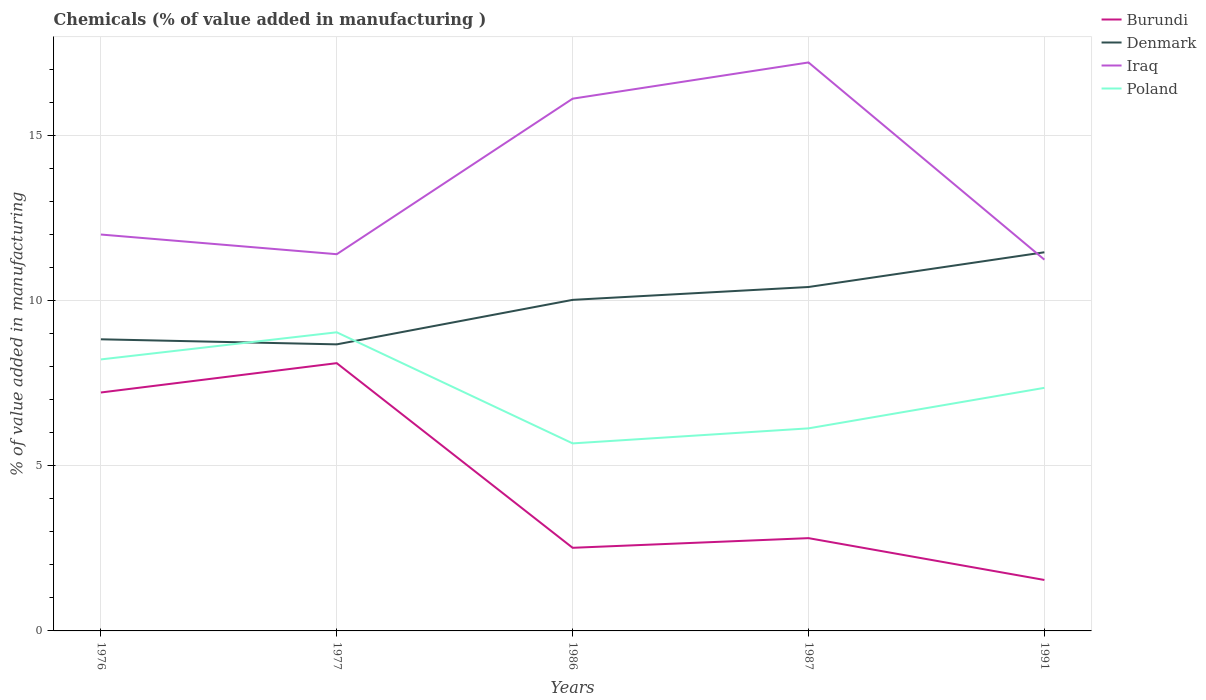Is the number of lines equal to the number of legend labels?
Provide a short and direct response. Yes. Across all years, what is the maximum value added in manufacturing chemicals in Denmark?
Offer a terse response. 8.68. In which year was the value added in manufacturing chemicals in Denmark maximum?
Keep it short and to the point. 1977. What is the total value added in manufacturing chemicals in Burundi in the graph?
Give a very brief answer. 5.68. What is the difference between the highest and the second highest value added in manufacturing chemicals in Burundi?
Give a very brief answer. 6.57. What is the difference between the highest and the lowest value added in manufacturing chemicals in Burundi?
Your answer should be compact. 2. Is the value added in manufacturing chemicals in Denmark strictly greater than the value added in manufacturing chemicals in Burundi over the years?
Provide a succinct answer. No. How many years are there in the graph?
Keep it short and to the point. 5. What is the difference between two consecutive major ticks on the Y-axis?
Your answer should be compact. 5. Does the graph contain grids?
Ensure brevity in your answer.  Yes. What is the title of the graph?
Offer a terse response. Chemicals (% of value added in manufacturing ). What is the label or title of the X-axis?
Provide a succinct answer. Years. What is the label or title of the Y-axis?
Provide a succinct answer. % of value added in manufacturing. What is the % of value added in manufacturing in Burundi in 1976?
Your answer should be compact. 7.22. What is the % of value added in manufacturing in Denmark in 1976?
Keep it short and to the point. 8.83. What is the % of value added in manufacturing in Iraq in 1976?
Your answer should be very brief. 12. What is the % of value added in manufacturing in Poland in 1976?
Offer a very short reply. 8.22. What is the % of value added in manufacturing of Burundi in 1977?
Give a very brief answer. 8.11. What is the % of value added in manufacturing in Denmark in 1977?
Provide a short and direct response. 8.68. What is the % of value added in manufacturing of Iraq in 1977?
Offer a very short reply. 11.41. What is the % of value added in manufacturing of Poland in 1977?
Your response must be concise. 9.04. What is the % of value added in manufacturing in Burundi in 1986?
Make the answer very short. 2.52. What is the % of value added in manufacturing in Denmark in 1986?
Offer a terse response. 10.02. What is the % of value added in manufacturing of Iraq in 1986?
Your response must be concise. 16.12. What is the % of value added in manufacturing in Poland in 1986?
Provide a succinct answer. 5.68. What is the % of value added in manufacturing of Burundi in 1987?
Make the answer very short. 2.81. What is the % of value added in manufacturing of Denmark in 1987?
Offer a very short reply. 10.41. What is the % of value added in manufacturing of Iraq in 1987?
Ensure brevity in your answer.  17.21. What is the % of value added in manufacturing in Poland in 1987?
Ensure brevity in your answer.  6.13. What is the % of value added in manufacturing of Burundi in 1991?
Provide a succinct answer. 1.54. What is the % of value added in manufacturing in Denmark in 1991?
Your response must be concise. 11.47. What is the % of value added in manufacturing in Iraq in 1991?
Make the answer very short. 11.24. What is the % of value added in manufacturing of Poland in 1991?
Keep it short and to the point. 7.36. Across all years, what is the maximum % of value added in manufacturing in Burundi?
Your answer should be very brief. 8.11. Across all years, what is the maximum % of value added in manufacturing in Denmark?
Offer a very short reply. 11.47. Across all years, what is the maximum % of value added in manufacturing of Iraq?
Make the answer very short. 17.21. Across all years, what is the maximum % of value added in manufacturing in Poland?
Your response must be concise. 9.04. Across all years, what is the minimum % of value added in manufacturing of Burundi?
Make the answer very short. 1.54. Across all years, what is the minimum % of value added in manufacturing in Denmark?
Ensure brevity in your answer.  8.68. Across all years, what is the minimum % of value added in manufacturing in Iraq?
Your answer should be very brief. 11.24. Across all years, what is the minimum % of value added in manufacturing of Poland?
Ensure brevity in your answer.  5.68. What is the total % of value added in manufacturing in Burundi in the graph?
Your response must be concise. 22.2. What is the total % of value added in manufacturing in Denmark in the graph?
Ensure brevity in your answer.  49.41. What is the total % of value added in manufacturing of Iraq in the graph?
Provide a succinct answer. 67.98. What is the total % of value added in manufacturing of Poland in the graph?
Your answer should be very brief. 36.44. What is the difference between the % of value added in manufacturing of Burundi in 1976 and that in 1977?
Offer a terse response. -0.89. What is the difference between the % of value added in manufacturing of Denmark in 1976 and that in 1977?
Offer a terse response. 0.15. What is the difference between the % of value added in manufacturing of Iraq in 1976 and that in 1977?
Make the answer very short. 0.6. What is the difference between the % of value added in manufacturing of Poland in 1976 and that in 1977?
Your response must be concise. -0.82. What is the difference between the % of value added in manufacturing of Burundi in 1976 and that in 1986?
Offer a terse response. 4.7. What is the difference between the % of value added in manufacturing of Denmark in 1976 and that in 1986?
Offer a very short reply. -1.19. What is the difference between the % of value added in manufacturing of Iraq in 1976 and that in 1986?
Ensure brevity in your answer.  -4.11. What is the difference between the % of value added in manufacturing of Poland in 1976 and that in 1986?
Offer a very short reply. 2.54. What is the difference between the % of value added in manufacturing in Burundi in 1976 and that in 1987?
Provide a short and direct response. 4.41. What is the difference between the % of value added in manufacturing in Denmark in 1976 and that in 1987?
Provide a succinct answer. -1.58. What is the difference between the % of value added in manufacturing of Iraq in 1976 and that in 1987?
Provide a succinct answer. -5.21. What is the difference between the % of value added in manufacturing of Poland in 1976 and that in 1987?
Ensure brevity in your answer.  2.09. What is the difference between the % of value added in manufacturing of Burundi in 1976 and that in 1991?
Provide a short and direct response. 5.68. What is the difference between the % of value added in manufacturing in Denmark in 1976 and that in 1991?
Offer a terse response. -2.63. What is the difference between the % of value added in manufacturing in Iraq in 1976 and that in 1991?
Offer a terse response. 0.76. What is the difference between the % of value added in manufacturing in Poland in 1976 and that in 1991?
Keep it short and to the point. 0.86. What is the difference between the % of value added in manufacturing in Burundi in 1977 and that in 1986?
Your response must be concise. 5.59. What is the difference between the % of value added in manufacturing of Denmark in 1977 and that in 1986?
Offer a very short reply. -1.35. What is the difference between the % of value added in manufacturing of Iraq in 1977 and that in 1986?
Make the answer very short. -4.71. What is the difference between the % of value added in manufacturing in Poland in 1977 and that in 1986?
Your answer should be very brief. 3.36. What is the difference between the % of value added in manufacturing of Burundi in 1977 and that in 1987?
Make the answer very short. 5.3. What is the difference between the % of value added in manufacturing of Denmark in 1977 and that in 1987?
Provide a short and direct response. -1.74. What is the difference between the % of value added in manufacturing in Iraq in 1977 and that in 1987?
Provide a succinct answer. -5.81. What is the difference between the % of value added in manufacturing in Poland in 1977 and that in 1987?
Provide a succinct answer. 2.91. What is the difference between the % of value added in manufacturing of Burundi in 1977 and that in 1991?
Offer a terse response. 6.57. What is the difference between the % of value added in manufacturing in Denmark in 1977 and that in 1991?
Offer a terse response. -2.79. What is the difference between the % of value added in manufacturing of Iraq in 1977 and that in 1991?
Offer a very short reply. 0.17. What is the difference between the % of value added in manufacturing of Poland in 1977 and that in 1991?
Keep it short and to the point. 1.68. What is the difference between the % of value added in manufacturing of Burundi in 1986 and that in 1987?
Your response must be concise. -0.29. What is the difference between the % of value added in manufacturing of Denmark in 1986 and that in 1987?
Provide a short and direct response. -0.39. What is the difference between the % of value added in manufacturing in Iraq in 1986 and that in 1987?
Your answer should be compact. -1.1. What is the difference between the % of value added in manufacturing in Poland in 1986 and that in 1987?
Provide a succinct answer. -0.46. What is the difference between the % of value added in manufacturing in Burundi in 1986 and that in 1991?
Make the answer very short. 0.97. What is the difference between the % of value added in manufacturing in Denmark in 1986 and that in 1991?
Make the answer very short. -1.44. What is the difference between the % of value added in manufacturing of Iraq in 1986 and that in 1991?
Provide a succinct answer. 4.87. What is the difference between the % of value added in manufacturing of Poland in 1986 and that in 1991?
Provide a short and direct response. -1.68. What is the difference between the % of value added in manufacturing in Burundi in 1987 and that in 1991?
Ensure brevity in your answer.  1.27. What is the difference between the % of value added in manufacturing of Denmark in 1987 and that in 1991?
Keep it short and to the point. -1.05. What is the difference between the % of value added in manufacturing of Iraq in 1987 and that in 1991?
Provide a short and direct response. 5.97. What is the difference between the % of value added in manufacturing in Poland in 1987 and that in 1991?
Keep it short and to the point. -1.23. What is the difference between the % of value added in manufacturing of Burundi in 1976 and the % of value added in manufacturing of Denmark in 1977?
Your response must be concise. -1.46. What is the difference between the % of value added in manufacturing of Burundi in 1976 and the % of value added in manufacturing of Iraq in 1977?
Give a very brief answer. -4.19. What is the difference between the % of value added in manufacturing in Burundi in 1976 and the % of value added in manufacturing in Poland in 1977?
Provide a short and direct response. -1.82. What is the difference between the % of value added in manufacturing of Denmark in 1976 and the % of value added in manufacturing of Iraq in 1977?
Make the answer very short. -2.58. What is the difference between the % of value added in manufacturing of Denmark in 1976 and the % of value added in manufacturing of Poland in 1977?
Provide a short and direct response. -0.21. What is the difference between the % of value added in manufacturing of Iraq in 1976 and the % of value added in manufacturing of Poland in 1977?
Make the answer very short. 2.96. What is the difference between the % of value added in manufacturing of Burundi in 1976 and the % of value added in manufacturing of Denmark in 1986?
Ensure brevity in your answer.  -2.8. What is the difference between the % of value added in manufacturing of Burundi in 1976 and the % of value added in manufacturing of Iraq in 1986?
Your answer should be very brief. -8.9. What is the difference between the % of value added in manufacturing in Burundi in 1976 and the % of value added in manufacturing in Poland in 1986?
Ensure brevity in your answer.  1.54. What is the difference between the % of value added in manufacturing in Denmark in 1976 and the % of value added in manufacturing in Iraq in 1986?
Make the answer very short. -7.29. What is the difference between the % of value added in manufacturing of Denmark in 1976 and the % of value added in manufacturing of Poland in 1986?
Your answer should be very brief. 3.15. What is the difference between the % of value added in manufacturing of Iraq in 1976 and the % of value added in manufacturing of Poland in 1986?
Give a very brief answer. 6.32. What is the difference between the % of value added in manufacturing of Burundi in 1976 and the % of value added in manufacturing of Denmark in 1987?
Offer a terse response. -3.19. What is the difference between the % of value added in manufacturing in Burundi in 1976 and the % of value added in manufacturing in Iraq in 1987?
Give a very brief answer. -9.99. What is the difference between the % of value added in manufacturing in Burundi in 1976 and the % of value added in manufacturing in Poland in 1987?
Your response must be concise. 1.09. What is the difference between the % of value added in manufacturing of Denmark in 1976 and the % of value added in manufacturing of Iraq in 1987?
Make the answer very short. -8.38. What is the difference between the % of value added in manufacturing of Denmark in 1976 and the % of value added in manufacturing of Poland in 1987?
Provide a succinct answer. 2.7. What is the difference between the % of value added in manufacturing of Iraq in 1976 and the % of value added in manufacturing of Poland in 1987?
Provide a short and direct response. 5.87. What is the difference between the % of value added in manufacturing of Burundi in 1976 and the % of value added in manufacturing of Denmark in 1991?
Your answer should be very brief. -4.25. What is the difference between the % of value added in manufacturing of Burundi in 1976 and the % of value added in manufacturing of Iraq in 1991?
Make the answer very short. -4.02. What is the difference between the % of value added in manufacturing in Burundi in 1976 and the % of value added in manufacturing in Poland in 1991?
Make the answer very short. -0.14. What is the difference between the % of value added in manufacturing in Denmark in 1976 and the % of value added in manufacturing in Iraq in 1991?
Offer a very short reply. -2.41. What is the difference between the % of value added in manufacturing of Denmark in 1976 and the % of value added in manufacturing of Poland in 1991?
Give a very brief answer. 1.47. What is the difference between the % of value added in manufacturing in Iraq in 1976 and the % of value added in manufacturing in Poland in 1991?
Your answer should be very brief. 4.64. What is the difference between the % of value added in manufacturing of Burundi in 1977 and the % of value added in manufacturing of Denmark in 1986?
Provide a succinct answer. -1.92. What is the difference between the % of value added in manufacturing in Burundi in 1977 and the % of value added in manufacturing in Iraq in 1986?
Your answer should be compact. -8.01. What is the difference between the % of value added in manufacturing in Burundi in 1977 and the % of value added in manufacturing in Poland in 1986?
Your answer should be compact. 2.43. What is the difference between the % of value added in manufacturing in Denmark in 1977 and the % of value added in manufacturing in Iraq in 1986?
Provide a succinct answer. -7.44. What is the difference between the % of value added in manufacturing in Denmark in 1977 and the % of value added in manufacturing in Poland in 1986?
Offer a very short reply. 3. What is the difference between the % of value added in manufacturing of Iraq in 1977 and the % of value added in manufacturing of Poland in 1986?
Your answer should be compact. 5.73. What is the difference between the % of value added in manufacturing of Burundi in 1977 and the % of value added in manufacturing of Denmark in 1987?
Your answer should be very brief. -2.31. What is the difference between the % of value added in manufacturing of Burundi in 1977 and the % of value added in manufacturing of Iraq in 1987?
Offer a very short reply. -9.11. What is the difference between the % of value added in manufacturing of Burundi in 1977 and the % of value added in manufacturing of Poland in 1987?
Your answer should be very brief. 1.97. What is the difference between the % of value added in manufacturing of Denmark in 1977 and the % of value added in manufacturing of Iraq in 1987?
Provide a short and direct response. -8.54. What is the difference between the % of value added in manufacturing of Denmark in 1977 and the % of value added in manufacturing of Poland in 1987?
Make the answer very short. 2.54. What is the difference between the % of value added in manufacturing of Iraq in 1977 and the % of value added in manufacturing of Poland in 1987?
Your answer should be very brief. 5.27. What is the difference between the % of value added in manufacturing in Burundi in 1977 and the % of value added in manufacturing in Denmark in 1991?
Offer a terse response. -3.36. What is the difference between the % of value added in manufacturing in Burundi in 1977 and the % of value added in manufacturing in Iraq in 1991?
Offer a very short reply. -3.13. What is the difference between the % of value added in manufacturing in Burundi in 1977 and the % of value added in manufacturing in Poland in 1991?
Keep it short and to the point. 0.75. What is the difference between the % of value added in manufacturing in Denmark in 1977 and the % of value added in manufacturing in Iraq in 1991?
Your response must be concise. -2.57. What is the difference between the % of value added in manufacturing of Denmark in 1977 and the % of value added in manufacturing of Poland in 1991?
Provide a succinct answer. 1.32. What is the difference between the % of value added in manufacturing in Iraq in 1977 and the % of value added in manufacturing in Poland in 1991?
Offer a terse response. 4.05. What is the difference between the % of value added in manufacturing of Burundi in 1986 and the % of value added in manufacturing of Denmark in 1987?
Offer a very short reply. -7.9. What is the difference between the % of value added in manufacturing of Burundi in 1986 and the % of value added in manufacturing of Iraq in 1987?
Your response must be concise. -14.7. What is the difference between the % of value added in manufacturing of Burundi in 1986 and the % of value added in manufacturing of Poland in 1987?
Keep it short and to the point. -3.62. What is the difference between the % of value added in manufacturing of Denmark in 1986 and the % of value added in manufacturing of Iraq in 1987?
Keep it short and to the point. -7.19. What is the difference between the % of value added in manufacturing of Denmark in 1986 and the % of value added in manufacturing of Poland in 1987?
Your answer should be very brief. 3.89. What is the difference between the % of value added in manufacturing of Iraq in 1986 and the % of value added in manufacturing of Poland in 1987?
Make the answer very short. 9.98. What is the difference between the % of value added in manufacturing in Burundi in 1986 and the % of value added in manufacturing in Denmark in 1991?
Give a very brief answer. -8.95. What is the difference between the % of value added in manufacturing in Burundi in 1986 and the % of value added in manufacturing in Iraq in 1991?
Offer a terse response. -8.73. What is the difference between the % of value added in manufacturing of Burundi in 1986 and the % of value added in manufacturing of Poland in 1991?
Make the answer very short. -4.84. What is the difference between the % of value added in manufacturing of Denmark in 1986 and the % of value added in manufacturing of Iraq in 1991?
Make the answer very short. -1.22. What is the difference between the % of value added in manufacturing in Denmark in 1986 and the % of value added in manufacturing in Poland in 1991?
Your answer should be very brief. 2.66. What is the difference between the % of value added in manufacturing of Iraq in 1986 and the % of value added in manufacturing of Poland in 1991?
Offer a very short reply. 8.76. What is the difference between the % of value added in manufacturing in Burundi in 1987 and the % of value added in manufacturing in Denmark in 1991?
Ensure brevity in your answer.  -8.66. What is the difference between the % of value added in manufacturing of Burundi in 1987 and the % of value added in manufacturing of Iraq in 1991?
Provide a short and direct response. -8.43. What is the difference between the % of value added in manufacturing in Burundi in 1987 and the % of value added in manufacturing in Poland in 1991?
Keep it short and to the point. -4.55. What is the difference between the % of value added in manufacturing in Denmark in 1987 and the % of value added in manufacturing in Iraq in 1991?
Make the answer very short. -0.83. What is the difference between the % of value added in manufacturing of Denmark in 1987 and the % of value added in manufacturing of Poland in 1991?
Your answer should be compact. 3.05. What is the difference between the % of value added in manufacturing of Iraq in 1987 and the % of value added in manufacturing of Poland in 1991?
Give a very brief answer. 9.85. What is the average % of value added in manufacturing in Burundi per year?
Ensure brevity in your answer.  4.44. What is the average % of value added in manufacturing in Denmark per year?
Provide a succinct answer. 9.88. What is the average % of value added in manufacturing in Iraq per year?
Give a very brief answer. 13.6. What is the average % of value added in manufacturing in Poland per year?
Provide a succinct answer. 7.29. In the year 1976, what is the difference between the % of value added in manufacturing of Burundi and % of value added in manufacturing of Denmark?
Ensure brevity in your answer.  -1.61. In the year 1976, what is the difference between the % of value added in manufacturing in Burundi and % of value added in manufacturing in Iraq?
Your answer should be very brief. -4.78. In the year 1976, what is the difference between the % of value added in manufacturing of Burundi and % of value added in manufacturing of Poland?
Offer a very short reply. -1. In the year 1976, what is the difference between the % of value added in manufacturing of Denmark and % of value added in manufacturing of Iraq?
Offer a very short reply. -3.17. In the year 1976, what is the difference between the % of value added in manufacturing of Denmark and % of value added in manufacturing of Poland?
Your answer should be compact. 0.61. In the year 1976, what is the difference between the % of value added in manufacturing of Iraq and % of value added in manufacturing of Poland?
Ensure brevity in your answer.  3.78. In the year 1977, what is the difference between the % of value added in manufacturing of Burundi and % of value added in manufacturing of Denmark?
Provide a short and direct response. -0.57. In the year 1977, what is the difference between the % of value added in manufacturing of Burundi and % of value added in manufacturing of Iraq?
Your answer should be compact. -3.3. In the year 1977, what is the difference between the % of value added in manufacturing in Burundi and % of value added in manufacturing in Poland?
Provide a succinct answer. -0.93. In the year 1977, what is the difference between the % of value added in manufacturing in Denmark and % of value added in manufacturing in Iraq?
Keep it short and to the point. -2.73. In the year 1977, what is the difference between the % of value added in manufacturing of Denmark and % of value added in manufacturing of Poland?
Provide a short and direct response. -0.37. In the year 1977, what is the difference between the % of value added in manufacturing of Iraq and % of value added in manufacturing of Poland?
Keep it short and to the point. 2.36. In the year 1986, what is the difference between the % of value added in manufacturing in Burundi and % of value added in manufacturing in Denmark?
Your answer should be compact. -7.51. In the year 1986, what is the difference between the % of value added in manufacturing in Burundi and % of value added in manufacturing in Iraq?
Your answer should be compact. -13.6. In the year 1986, what is the difference between the % of value added in manufacturing in Burundi and % of value added in manufacturing in Poland?
Your answer should be compact. -3.16. In the year 1986, what is the difference between the % of value added in manufacturing in Denmark and % of value added in manufacturing in Iraq?
Make the answer very short. -6.09. In the year 1986, what is the difference between the % of value added in manufacturing in Denmark and % of value added in manufacturing in Poland?
Offer a terse response. 4.35. In the year 1986, what is the difference between the % of value added in manufacturing in Iraq and % of value added in manufacturing in Poland?
Give a very brief answer. 10.44. In the year 1987, what is the difference between the % of value added in manufacturing in Burundi and % of value added in manufacturing in Denmark?
Your answer should be compact. -7.61. In the year 1987, what is the difference between the % of value added in manufacturing of Burundi and % of value added in manufacturing of Iraq?
Make the answer very short. -14.4. In the year 1987, what is the difference between the % of value added in manufacturing of Burundi and % of value added in manufacturing of Poland?
Your response must be concise. -3.32. In the year 1987, what is the difference between the % of value added in manufacturing in Denmark and % of value added in manufacturing in Iraq?
Your answer should be compact. -6.8. In the year 1987, what is the difference between the % of value added in manufacturing of Denmark and % of value added in manufacturing of Poland?
Ensure brevity in your answer.  4.28. In the year 1987, what is the difference between the % of value added in manufacturing of Iraq and % of value added in manufacturing of Poland?
Ensure brevity in your answer.  11.08. In the year 1991, what is the difference between the % of value added in manufacturing in Burundi and % of value added in manufacturing in Denmark?
Make the answer very short. -9.92. In the year 1991, what is the difference between the % of value added in manufacturing in Burundi and % of value added in manufacturing in Iraq?
Your response must be concise. -9.7. In the year 1991, what is the difference between the % of value added in manufacturing in Burundi and % of value added in manufacturing in Poland?
Keep it short and to the point. -5.82. In the year 1991, what is the difference between the % of value added in manufacturing of Denmark and % of value added in manufacturing of Iraq?
Your response must be concise. 0.22. In the year 1991, what is the difference between the % of value added in manufacturing in Denmark and % of value added in manufacturing in Poland?
Provide a short and direct response. 4.11. In the year 1991, what is the difference between the % of value added in manufacturing in Iraq and % of value added in manufacturing in Poland?
Your answer should be compact. 3.88. What is the ratio of the % of value added in manufacturing of Burundi in 1976 to that in 1977?
Your answer should be very brief. 0.89. What is the ratio of the % of value added in manufacturing in Denmark in 1976 to that in 1977?
Ensure brevity in your answer.  1.02. What is the ratio of the % of value added in manufacturing in Iraq in 1976 to that in 1977?
Your answer should be compact. 1.05. What is the ratio of the % of value added in manufacturing in Poland in 1976 to that in 1977?
Provide a succinct answer. 0.91. What is the ratio of the % of value added in manufacturing of Burundi in 1976 to that in 1986?
Offer a terse response. 2.87. What is the ratio of the % of value added in manufacturing in Denmark in 1976 to that in 1986?
Your answer should be compact. 0.88. What is the ratio of the % of value added in manufacturing of Iraq in 1976 to that in 1986?
Keep it short and to the point. 0.74. What is the ratio of the % of value added in manufacturing of Poland in 1976 to that in 1986?
Make the answer very short. 1.45. What is the ratio of the % of value added in manufacturing in Burundi in 1976 to that in 1987?
Your response must be concise. 2.57. What is the ratio of the % of value added in manufacturing in Denmark in 1976 to that in 1987?
Offer a terse response. 0.85. What is the ratio of the % of value added in manufacturing in Iraq in 1976 to that in 1987?
Your answer should be very brief. 0.7. What is the ratio of the % of value added in manufacturing in Poland in 1976 to that in 1987?
Give a very brief answer. 1.34. What is the ratio of the % of value added in manufacturing of Burundi in 1976 to that in 1991?
Make the answer very short. 4.68. What is the ratio of the % of value added in manufacturing of Denmark in 1976 to that in 1991?
Offer a very short reply. 0.77. What is the ratio of the % of value added in manufacturing in Iraq in 1976 to that in 1991?
Keep it short and to the point. 1.07. What is the ratio of the % of value added in manufacturing of Poland in 1976 to that in 1991?
Make the answer very short. 1.12. What is the ratio of the % of value added in manufacturing of Burundi in 1977 to that in 1986?
Offer a terse response. 3.22. What is the ratio of the % of value added in manufacturing of Denmark in 1977 to that in 1986?
Offer a terse response. 0.87. What is the ratio of the % of value added in manufacturing in Iraq in 1977 to that in 1986?
Make the answer very short. 0.71. What is the ratio of the % of value added in manufacturing in Poland in 1977 to that in 1986?
Make the answer very short. 1.59. What is the ratio of the % of value added in manufacturing of Burundi in 1977 to that in 1987?
Keep it short and to the point. 2.89. What is the ratio of the % of value added in manufacturing of Denmark in 1977 to that in 1987?
Offer a terse response. 0.83. What is the ratio of the % of value added in manufacturing of Iraq in 1977 to that in 1987?
Make the answer very short. 0.66. What is the ratio of the % of value added in manufacturing in Poland in 1977 to that in 1987?
Give a very brief answer. 1.47. What is the ratio of the % of value added in manufacturing of Burundi in 1977 to that in 1991?
Your response must be concise. 5.26. What is the ratio of the % of value added in manufacturing of Denmark in 1977 to that in 1991?
Give a very brief answer. 0.76. What is the ratio of the % of value added in manufacturing in Iraq in 1977 to that in 1991?
Offer a terse response. 1.01. What is the ratio of the % of value added in manufacturing in Poland in 1977 to that in 1991?
Your response must be concise. 1.23. What is the ratio of the % of value added in manufacturing of Burundi in 1986 to that in 1987?
Offer a very short reply. 0.9. What is the ratio of the % of value added in manufacturing of Denmark in 1986 to that in 1987?
Ensure brevity in your answer.  0.96. What is the ratio of the % of value added in manufacturing of Iraq in 1986 to that in 1987?
Keep it short and to the point. 0.94. What is the ratio of the % of value added in manufacturing of Poland in 1986 to that in 1987?
Offer a terse response. 0.93. What is the ratio of the % of value added in manufacturing of Burundi in 1986 to that in 1991?
Make the answer very short. 1.63. What is the ratio of the % of value added in manufacturing of Denmark in 1986 to that in 1991?
Make the answer very short. 0.87. What is the ratio of the % of value added in manufacturing in Iraq in 1986 to that in 1991?
Make the answer very short. 1.43. What is the ratio of the % of value added in manufacturing of Poland in 1986 to that in 1991?
Offer a very short reply. 0.77. What is the ratio of the % of value added in manufacturing of Burundi in 1987 to that in 1991?
Provide a short and direct response. 1.82. What is the ratio of the % of value added in manufacturing of Denmark in 1987 to that in 1991?
Provide a succinct answer. 0.91. What is the ratio of the % of value added in manufacturing of Iraq in 1987 to that in 1991?
Provide a short and direct response. 1.53. What is the difference between the highest and the second highest % of value added in manufacturing in Burundi?
Keep it short and to the point. 0.89. What is the difference between the highest and the second highest % of value added in manufacturing of Denmark?
Make the answer very short. 1.05. What is the difference between the highest and the second highest % of value added in manufacturing in Iraq?
Ensure brevity in your answer.  1.1. What is the difference between the highest and the second highest % of value added in manufacturing in Poland?
Make the answer very short. 0.82. What is the difference between the highest and the lowest % of value added in manufacturing in Burundi?
Make the answer very short. 6.57. What is the difference between the highest and the lowest % of value added in manufacturing in Denmark?
Offer a terse response. 2.79. What is the difference between the highest and the lowest % of value added in manufacturing in Iraq?
Provide a short and direct response. 5.97. What is the difference between the highest and the lowest % of value added in manufacturing of Poland?
Give a very brief answer. 3.36. 